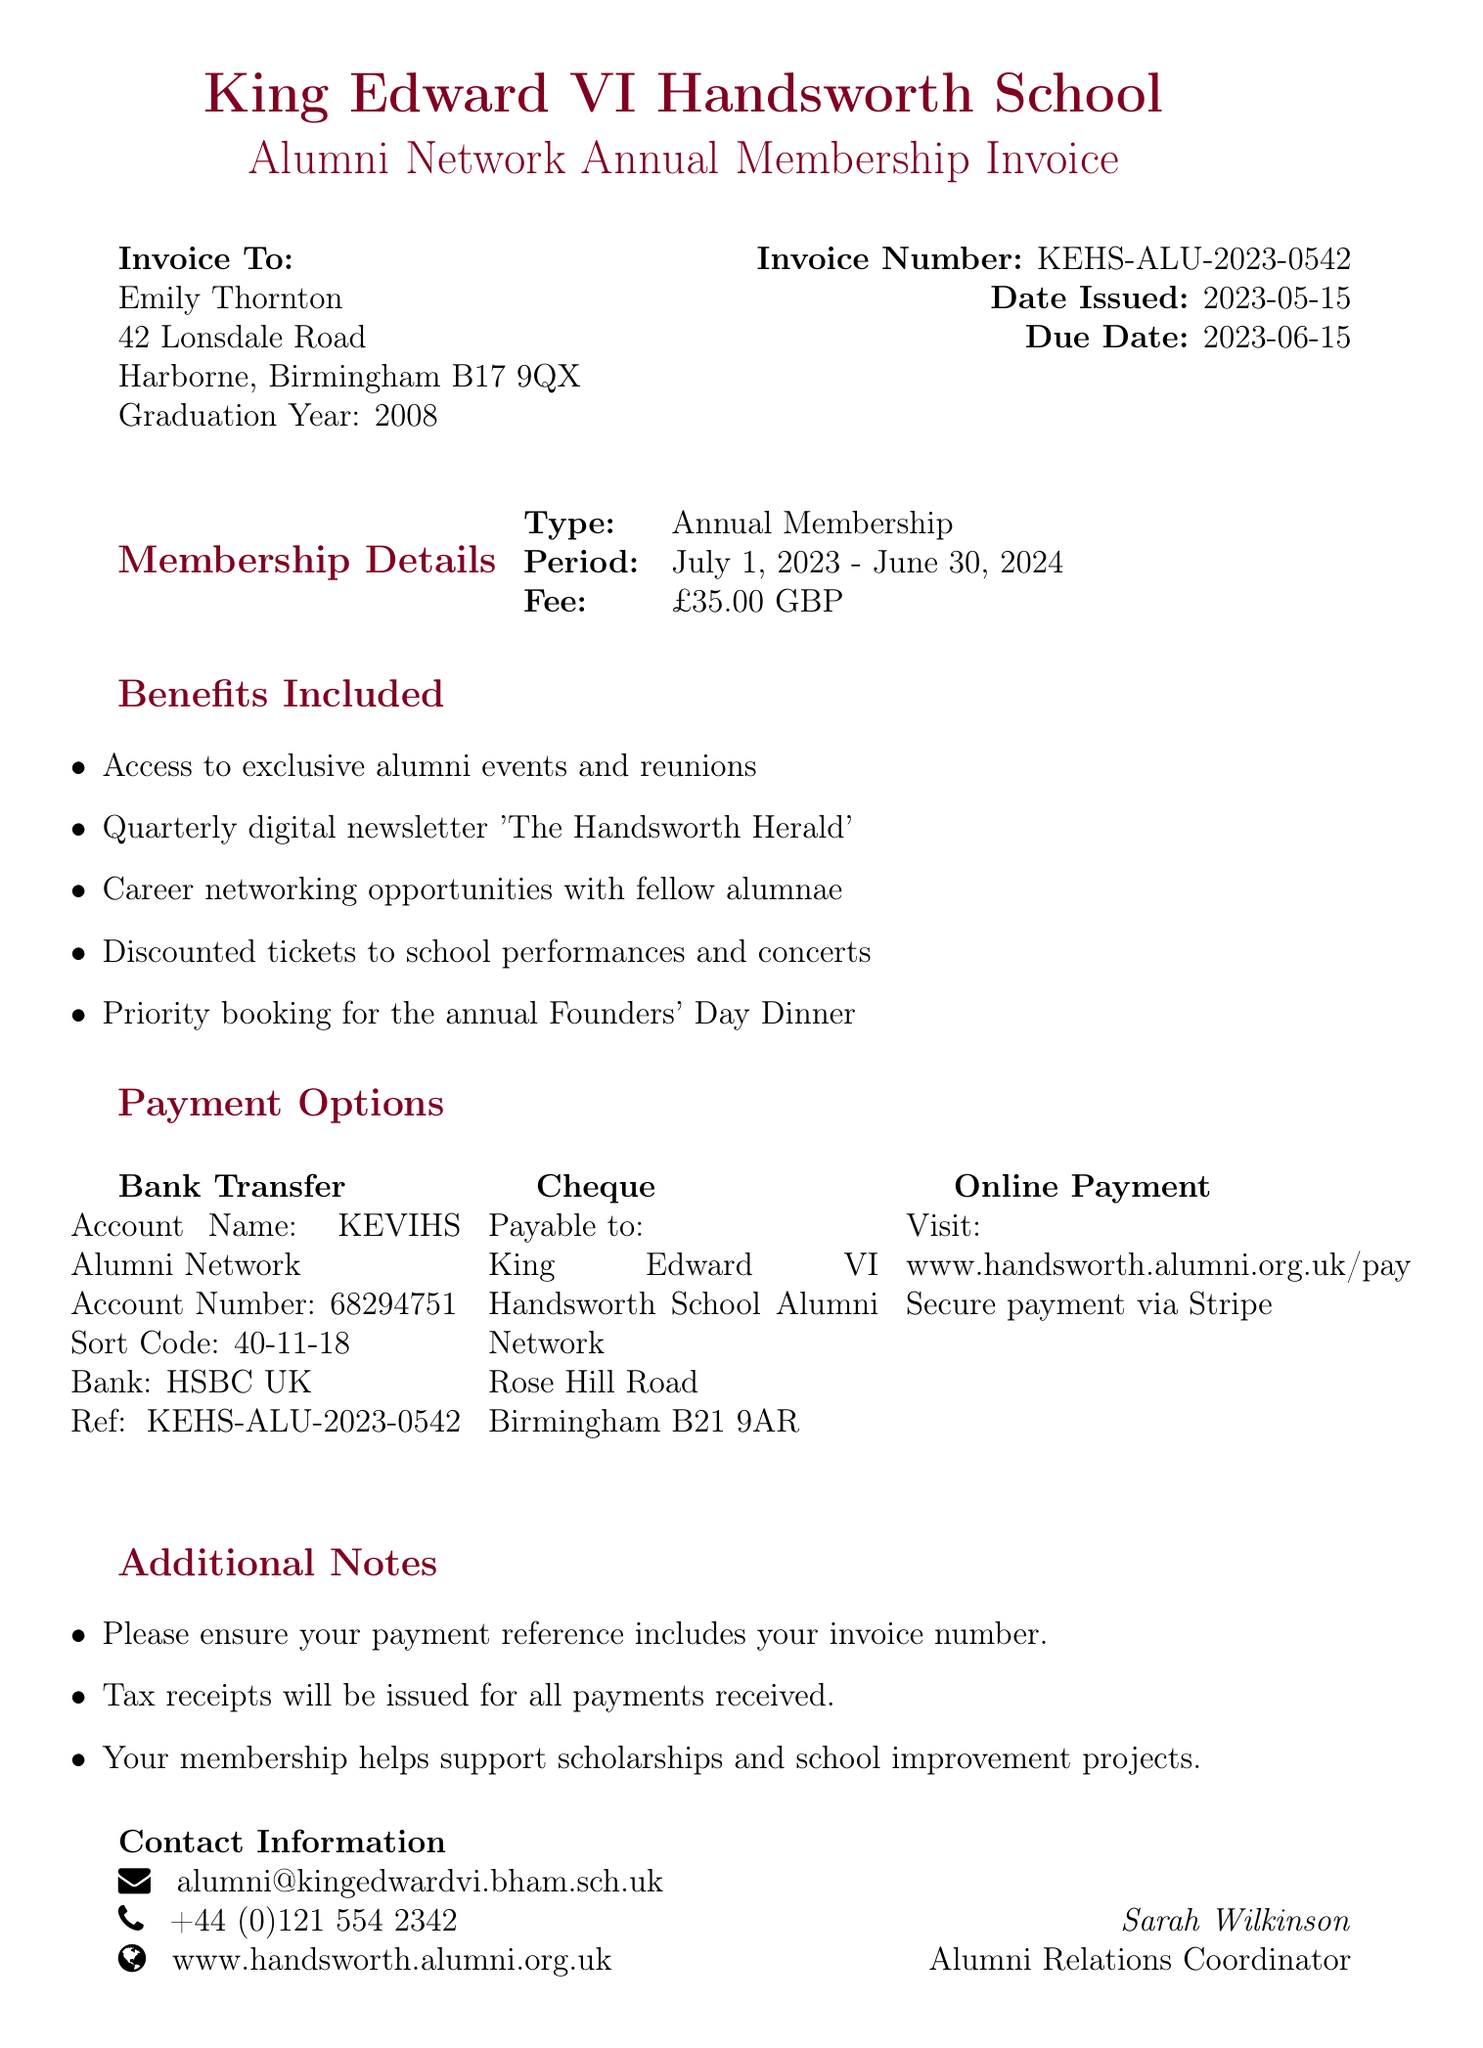What is the invoice number? The invoice number is explicitly stated in the document, identifying this specific transaction.
Answer: KEHS-ALU-2023-0542 What is the membership fee? The membership fee is clearly mentioned as the amount due for the annual membership.
Answer: £35.00 Who is the Alumni Relations Coordinator? The document designates the person responsible for alumni relations, providing their position and name.
Answer: Sarah Wilkinson What is the period of the membership? The document specifies the timeframe during which the membership is active, covering a whole year.
Answer: July 1, 2023 - June 30, 2024 What is the due date for the payment? The due date for the membership fee payment is explicitly declared in the invoice details.
Answer: 2023-06-15 Which payment method requires a reference? The document notes that one of the payment options entails including a specific reference with the payment details.
Answer: Bank Transfer How are tax receipts handled? The document provides information about the issuance of tax receipts concerning payment.
Answer: Tax receipts will be issued What do alumni members gain access to? The benefits section outlines various exclusive opportunities available to alumni members.
Answer: Exclusive alumni events and reunions What is the email contact for the Alumni Network? The document lists a contact email for further inquiries related to alumni membership.
Answer: alumni@kingedwardvi.bham.sch.uk 